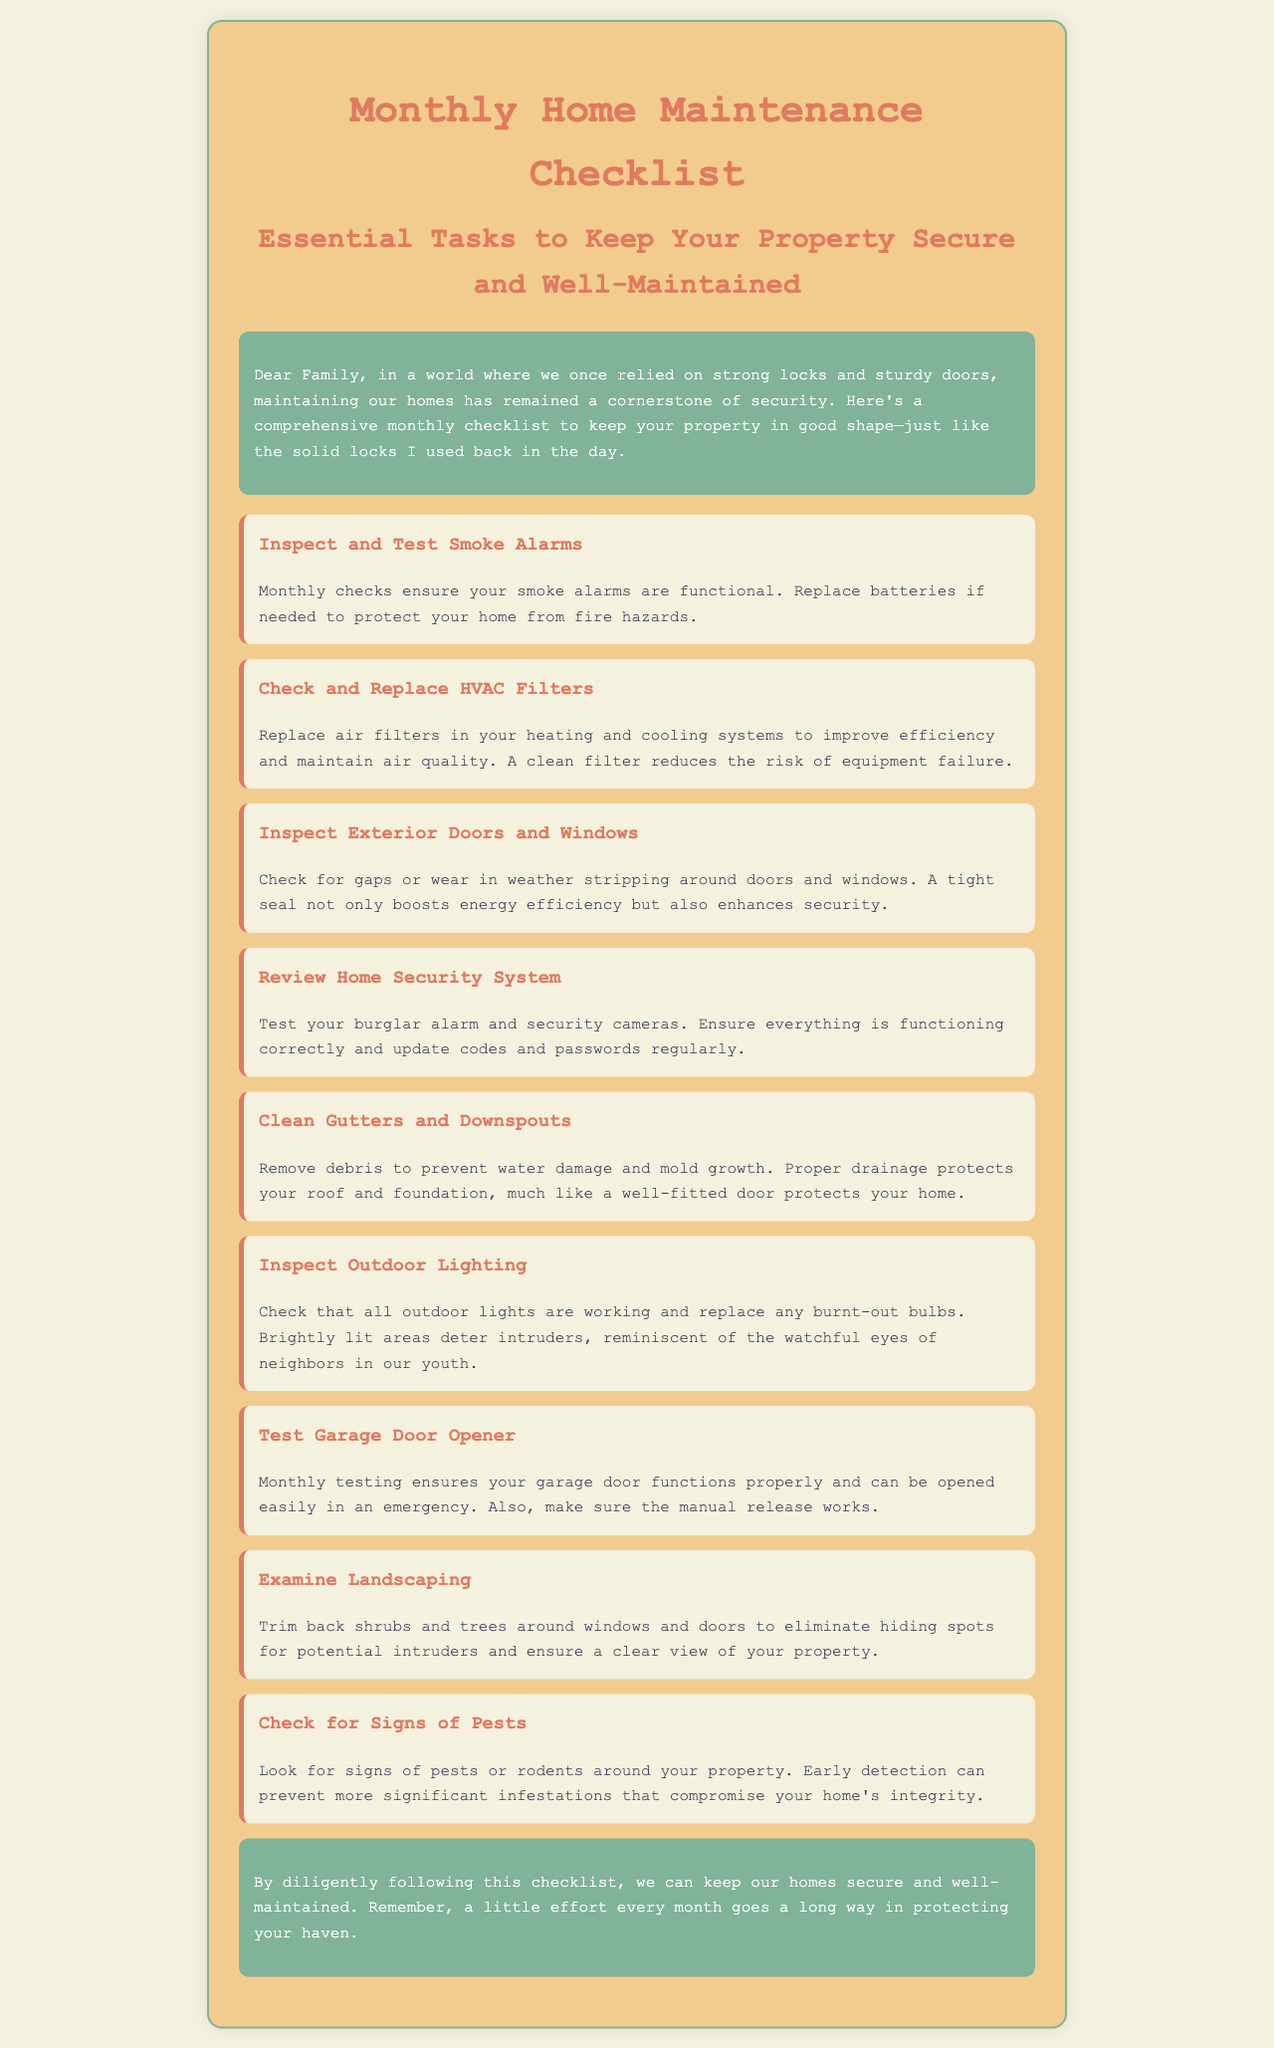What is the title of the document? The title of the document is typically presented at the top and indicates the subject matter.
Answer: Monthly Home Maintenance Checklist How many tasks are listed in the document? The total number of tasks can be counted from the section presenting them.
Answer: Nine What is the first task mentioned? The first task in the checklist is the initial item listed under "tasks".
Answer: Inspect and Test Smoke Alarms What is the purpose of replacing HVAC filters? The reason for replacing filters is typically to improve efficiency and maintain air quality, highlighted in the relevant task.
Answer: Improve efficiency What should you do with outdoor lighting? The task details the maintenance needed for outdoor lighting, specifying a particular action to be taken.
Answer: Check that all outdoor lights are working What is a consequence of not cleaning gutters? The tasks often indicate potential problems resulting from neglecting maintenance, providing the rationale for the task.
Answer: Water damage What does the introductory paragraph emphasize? The introduction summarizes the overall theme of the document, conveying its main message about home security.
Answer: Maintaining our homes What action should be taken regarding the garage door opener? This task instructs what needs to be done monthly concerning the garage door operation.
Answer: Monthly testing Why should shrubs and trees be trimmed? The reasoning behind maintaining landscaping is often tied to security concerns addressed in the document.
Answer: Eliminate hiding spots 